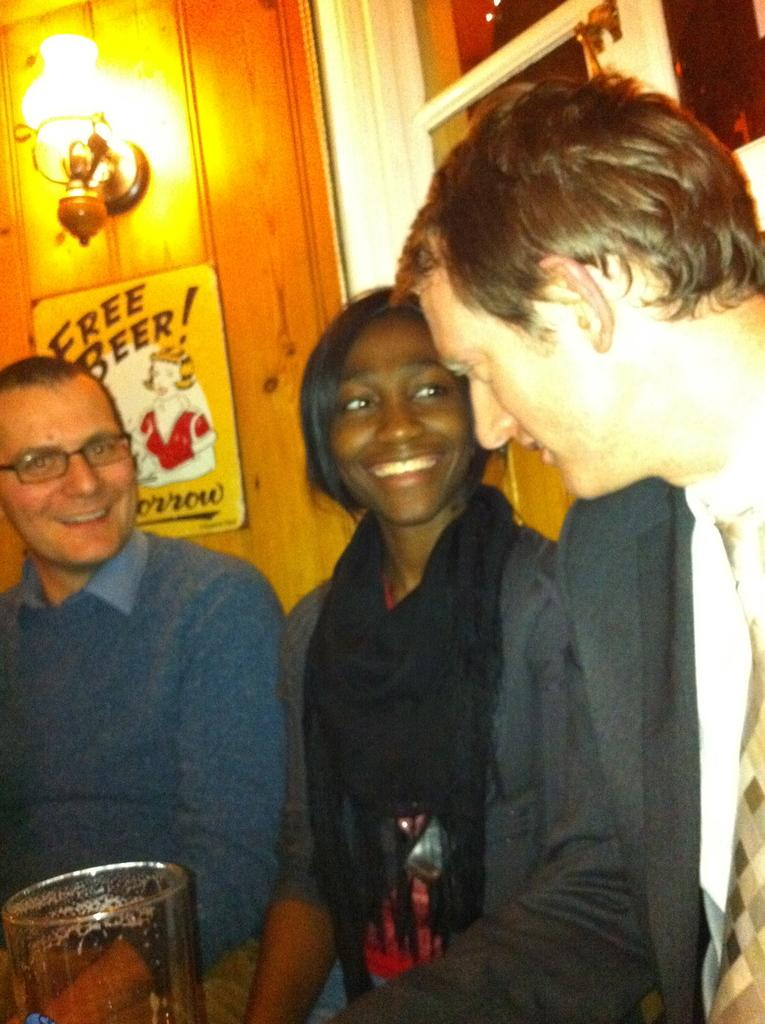How many people are in the image? There are three people in the image: one woman and two men. What is the position of the woman in relation to the men? The woman is standing between the two men. What object is in front of the group? There is a beer glass in front of the group. What type of lighting fixture is present in the image? There is a lamp in the image. What architectural feature is visible in the image? There is a window in the image. Can you see a spade in the image? No, there is no spade present in the image. 